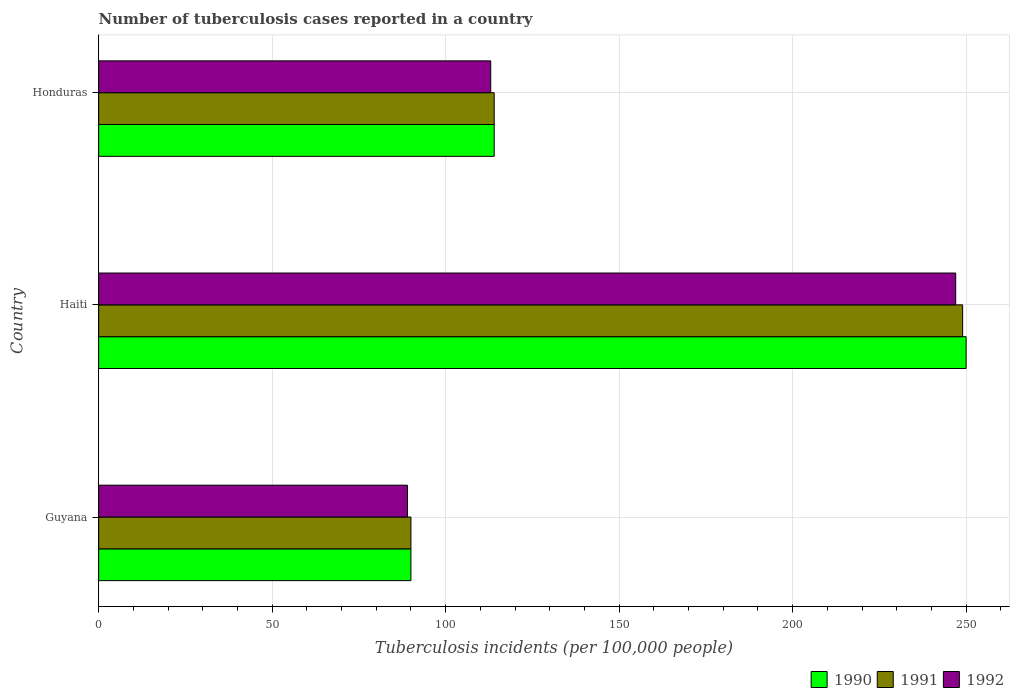How many different coloured bars are there?
Your response must be concise. 3. Are the number of bars on each tick of the Y-axis equal?
Provide a short and direct response. Yes. How many bars are there on the 2nd tick from the top?
Give a very brief answer. 3. How many bars are there on the 3rd tick from the bottom?
Offer a very short reply. 3. What is the label of the 2nd group of bars from the top?
Make the answer very short. Haiti. What is the number of tuberculosis cases reported in in 1992 in Honduras?
Give a very brief answer. 113. Across all countries, what is the maximum number of tuberculosis cases reported in in 1992?
Your answer should be compact. 247. Across all countries, what is the minimum number of tuberculosis cases reported in in 1992?
Provide a succinct answer. 89. In which country was the number of tuberculosis cases reported in in 1990 maximum?
Keep it short and to the point. Haiti. In which country was the number of tuberculosis cases reported in in 1991 minimum?
Your answer should be compact. Guyana. What is the total number of tuberculosis cases reported in in 1990 in the graph?
Ensure brevity in your answer.  454. What is the difference between the number of tuberculosis cases reported in in 1992 in Guyana and that in Haiti?
Your answer should be very brief. -158. What is the difference between the number of tuberculosis cases reported in in 1992 in Honduras and the number of tuberculosis cases reported in in 1991 in Haiti?
Make the answer very short. -136. What is the average number of tuberculosis cases reported in in 1992 per country?
Ensure brevity in your answer.  149.67. What is the difference between the number of tuberculosis cases reported in in 1991 and number of tuberculosis cases reported in in 1992 in Haiti?
Offer a terse response. 2. In how many countries, is the number of tuberculosis cases reported in in 1991 greater than 80 ?
Your response must be concise. 3. What is the ratio of the number of tuberculosis cases reported in in 1990 in Haiti to that in Honduras?
Keep it short and to the point. 2.19. Is the number of tuberculosis cases reported in in 1992 in Haiti less than that in Honduras?
Make the answer very short. No. Is the difference between the number of tuberculosis cases reported in in 1991 in Haiti and Honduras greater than the difference between the number of tuberculosis cases reported in in 1992 in Haiti and Honduras?
Your answer should be very brief. Yes. What is the difference between the highest and the second highest number of tuberculosis cases reported in in 1992?
Your answer should be compact. 134. What is the difference between the highest and the lowest number of tuberculosis cases reported in in 1992?
Your response must be concise. 158. Is the sum of the number of tuberculosis cases reported in in 1991 in Guyana and Haiti greater than the maximum number of tuberculosis cases reported in in 1992 across all countries?
Ensure brevity in your answer.  Yes. What does the 3rd bar from the bottom in Guyana represents?
Provide a succinct answer. 1992. Are all the bars in the graph horizontal?
Offer a terse response. Yes. Are the values on the major ticks of X-axis written in scientific E-notation?
Offer a very short reply. No. Does the graph contain grids?
Ensure brevity in your answer.  Yes. What is the title of the graph?
Provide a succinct answer. Number of tuberculosis cases reported in a country. Does "1997" appear as one of the legend labels in the graph?
Offer a very short reply. No. What is the label or title of the X-axis?
Provide a short and direct response. Tuberculosis incidents (per 100,0 people). What is the Tuberculosis incidents (per 100,000 people) of 1991 in Guyana?
Provide a succinct answer. 90. What is the Tuberculosis incidents (per 100,000 people) in 1992 in Guyana?
Make the answer very short. 89. What is the Tuberculosis incidents (per 100,000 people) in 1990 in Haiti?
Offer a terse response. 250. What is the Tuberculosis incidents (per 100,000 people) of 1991 in Haiti?
Make the answer very short. 249. What is the Tuberculosis incidents (per 100,000 people) in 1992 in Haiti?
Provide a succinct answer. 247. What is the Tuberculosis incidents (per 100,000 people) in 1990 in Honduras?
Keep it short and to the point. 114. What is the Tuberculosis incidents (per 100,000 people) in 1991 in Honduras?
Give a very brief answer. 114. What is the Tuberculosis incidents (per 100,000 people) of 1992 in Honduras?
Keep it short and to the point. 113. Across all countries, what is the maximum Tuberculosis incidents (per 100,000 people) in 1990?
Ensure brevity in your answer.  250. Across all countries, what is the maximum Tuberculosis incidents (per 100,000 people) of 1991?
Your answer should be very brief. 249. Across all countries, what is the maximum Tuberculosis incidents (per 100,000 people) of 1992?
Keep it short and to the point. 247. Across all countries, what is the minimum Tuberculosis incidents (per 100,000 people) of 1990?
Offer a terse response. 90. Across all countries, what is the minimum Tuberculosis incidents (per 100,000 people) in 1992?
Ensure brevity in your answer.  89. What is the total Tuberculosis incidents (per 100,000 people) of 1990 in the graph?
Make the answer very short. 454. What is the total Tuberculosis incidents (per 100,000 people) in 1991 in the graph?
Make the answer very short. 453. What is the total Tuberculosis incidents (per 100,000 people) of 1992 in the graph?
Your response must be concise. 449. What is the difference between the Tuberculosis incidents (per 100,000 people) of 1990 in Guyana and that in Haiti?
Provide a short and direct response. -160. What is the difference between the Tuberculosis incidents (per 100,000 people) in 1991 in Guyana and that in Haiti?
Your answer should be compact. -159. What is the difference between the Tuberculosis incidents (per 100,000 people) of 1992 in Guyana and that in Haiti?
Offer a terse response. -158. What is the difference between the Tuberculosis incidents (per 100,000 people) in 1990 in Guyana and that in Honduras?
Your response must be concise. -24. What is the difference between the Tuberculosis incidents (per 100,000 people) in 1992 in Guyana and that in Honduras?
Give a very brief answer. -24. What is the difference between the Tuberculosis incidents (per 100,000 people) in 1990 in Haiti and that in Honduras?
Your answer should be compact. 136. What is the difference between the Tuberculosis incidents (per 100,000 people) in 1991 in Haiti and that in Honduras?
Your response must be concise. 135. What is the difference between the Tuberculosis incidents (per 100,000 people) of 1992 in Haiti and that in Honduras?
Your answer should be compact. 134. What is the difference between the Tuberculosis incidents (per 100,000 people) in 1990 in Guyana and the Tuberculosis incidents (per 100,000 people) in 1991 in Haiti?
Offer a terse response. -159. What is the difference between the Tuberculosis incidents (per 100,000 people) of 1990 in Guyana and the Tuberculosis incidents (per 100,000 people) of 1992 in Haiti?
Keep it short and to the point. -157. What is the difference between the Tuberculosis incidents (per 100,000 people) of 1991 in Guyana and the Tuberculosis incidents (per 100,000 people) of 1992 in Haiti?
Give a very brief answer. -157. What is the difference between the Tuberculosis incidents (per 100,000 people) of 1990 in Guyana and the Tuberculosis incidents (per 100,000 people) of 1992 in Honduras?
Your response must be concise. -23. What is the difference between the Tuberculosis incidents (per 100,000 people) of 1991 in Guyana and the Tuberculosis incidents (per 100,000 people) of 1992 in Honduras?
Offer a terse response. -23. What is the difference between the Tuberculosis incidents (per 100,000 people) in 1990 in Haiti and the Tuberculosis incidents (per 100,000 people) in 1991 in Honduras?
Provide a short and direct response. 136. What is the difference between the Tuberculosis incidents (per 100,000 people) in 1990 in Haiti and the Tuberculosis incidents (per 100,000 people) in 1992 in Honduras?
Your answer should be very brief. 137. What is the difference between the Tuberculosis incidents (per 100,000 people) in 1991 in Haiti and the Tuberculosis incidents (per 100,000 people) in 1992 in Honduras?
Provide a short and direct response. 136. What is the average Tuberculosis incidents (per 100,000 people) in 1990 per country?
Your answer should be very brief. 151.33. What is the average Tuberculosis incidents (per 100,000 people) of 1991 per country?
Your answer should be very brief. 151. What is the average Tuberculosis incidents (per 100,000 people) in 1992 per country?
Provide a succinct answer. 149.67. What is the difference between the Tuberculosis incidents (per 100,000 people) in 1990 and Tuberculosis incidents (per 100,000 people) in 1991 in Guyana?
Provide a short and direct response. 0. What is the difference between the Tuberculosis incidents (per 100,000 people) of 1990 and Tuberculosis incidents (per 100,000 people) of 1992 in Haiti?
Keep it short and to the point. 3. What is the difference between the Tuberculosis incidents (per 100,000 people) in 1991 and Tuberculosis incidents (per 100,000 people) in 1992 in Haiti?
Provide a short and direct response. 2. What is the difference between the Tuberculosis incidents (per 100,000 people) of 1990 and Tuberculosis incidents (per 100,000 people) of 1991 in Honduras?
Offer a terse response. 0. What is the difference between the Tuberculosis incidents (per 100,000 people) of 1990 and Tuberculosis incidents (per 100,000 people) of 1992 in Honduras?
Keep it short and to the point. 1. What is the difference between the Tuberculosis incidents (per 100,000 people) of 1991 and Tuberculosis incidents (per 100,000 people) of 1992 in Honduras?
Provide a short and direct response. 1. What is the ratio of the Tuberculosis incidents (per 100,000 people) of 1990 in Guyana to that in Haiti?
Your answer should be very brief. 0.36. What is the ratio of the Tuberculosis incidents (per 100,000 people) in 1991 in Guyana to that in Haiti?
Keep it short and to the point. 0.36. What is the ratio of the Tuberculosis incidents (per 100,000 people) of 1992 in Guyana to that in Haiti?
Provide a short and direct response. 0.36. What is the ratio of the Tuberculosis incidents (per 100,000 people) in 1990 in Guyana to that in Honduras?
Provide a short and direct response. 0.79. What is the ratio of the Tuberculosis incidents (per 100,000 people) of 1991 in Guyana to that in Honduras?
Ensure brevity in your answer.  0.79. What is the ratio of the Tuberculosis incidents (per 100,000 people) in 1992 in Guyana to that in Honduras?
Your answer should be compact. 0.79. What is the ratio of the Tuberculosis incidents (per 100,000 people) in 1990 in Haiti to that in Honduras?
Give a very brief answer. 2.19. What is the ratio of the Tuberculosis incidents (per 100,000 people) of 1991 in Haiti to that in Honduras?
Provide a short and direct response. 2.18. What is the ratio of the Tuberculosis incidents (per 100,000 people) of 1992 in Haiti to that in Honduras?
Give a very brief answer. 2.19. What is the difference between the highest and the second highest Tuberculosis incidents (per 100,000 people) in 1990?
Ensure brevity in your answer.  136. What is the difference between the highest and the second highest Tuberculosis incidents (per 100,000 people) of 1991?
Ensure brevity in your answer.  135. What is the difference between the highest and the second highest Tuberculosis incidents (per 100,000 people) in 1992?
Provide a succinct answer. 134. What is the difference between the highest and the lowest Tuberculosis incidents (per 100,000 people) of 1990?
Offer a terse response. 160. What is the difference between the highest and the lowest Tuberculosis incidents (per 100,000 people) of 1991?
Offer a very short reply. 159. What is the difference between the highest and the lowest Tuberculosis incidents (per 100,000 people) in 1992?
Provide a short and direct response. 158. 